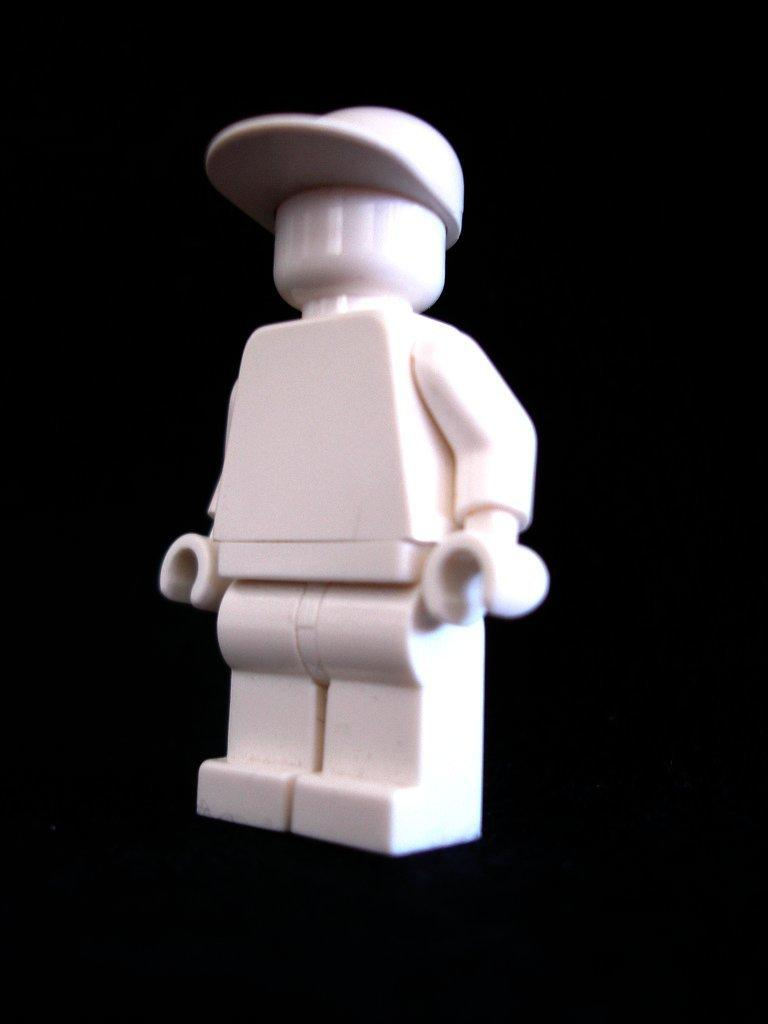What type of toy is present in the image? The image contains a white color toy. Can you describe any specific features of the toy? The toy has a white cap. What is the annual income of the toy in the image? The image does not provide any information about the toy's income, as it is an inanimate object and does not have an income. 